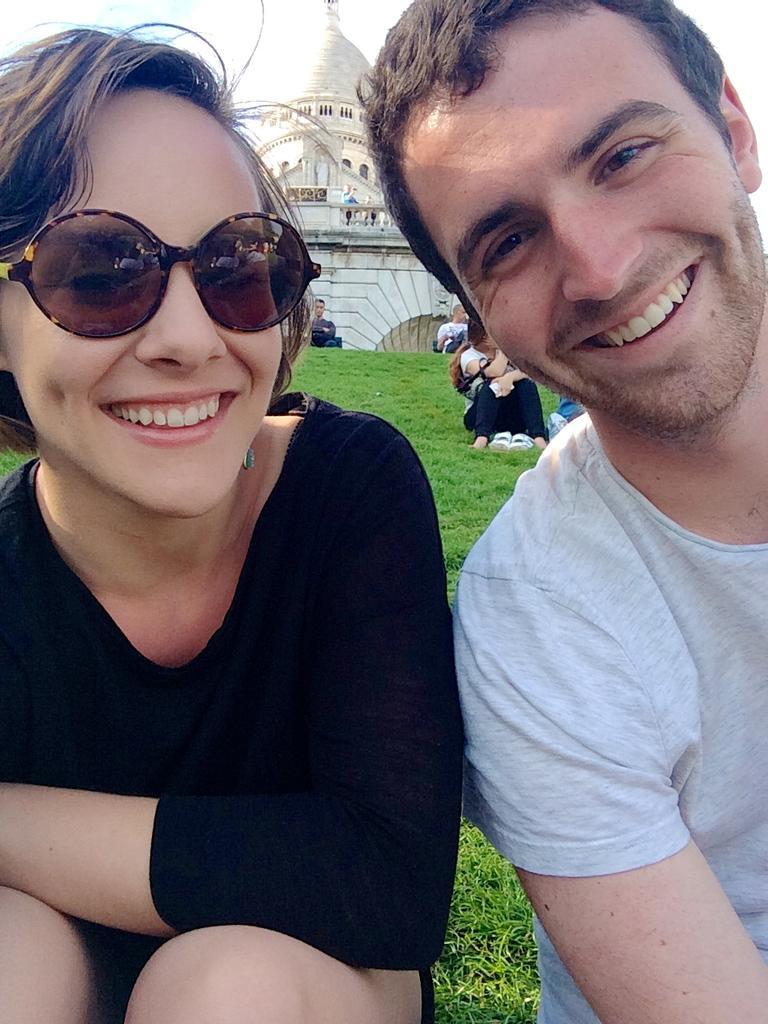Could you give a brief overview of what you see in this image? Here we can see a woman and a man. They are smiling and she has goggles. In the background we can see a building and few persons. 